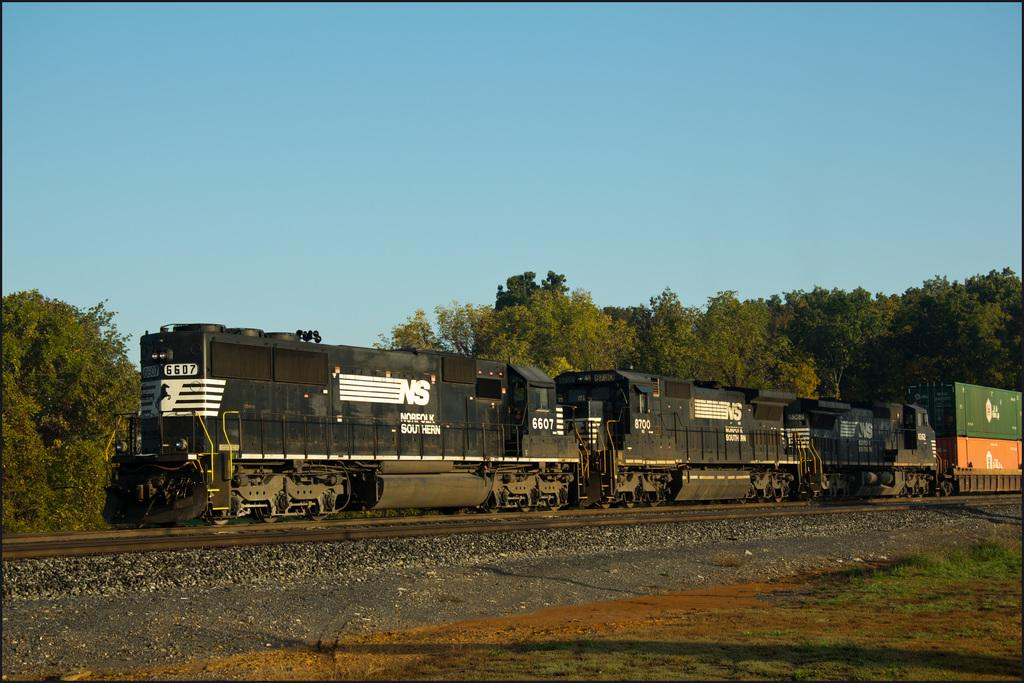What is the main subject of the image? The main subject of the image is a train. Where is the train located in the image? The train is on a railway track. What type of vegetation can be seen in the image? There are trees visible in the image. What is the color of the sky in the image? The sky is blue in the image. What is the color of the train? The train is black in color. What type of ground surface is visible in the image? There is grass on the ground in the image. What type of yarn is being used to knit a sweater for the lawyer in the image? There is no lawyer or yarn present in the image; it features a train on a railway track with trees, a blue sky, and grass on the ground. 